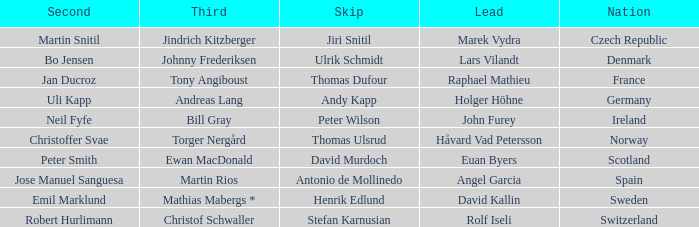Which Skip has a Third of tony angiboust? Thomas Dufour. 